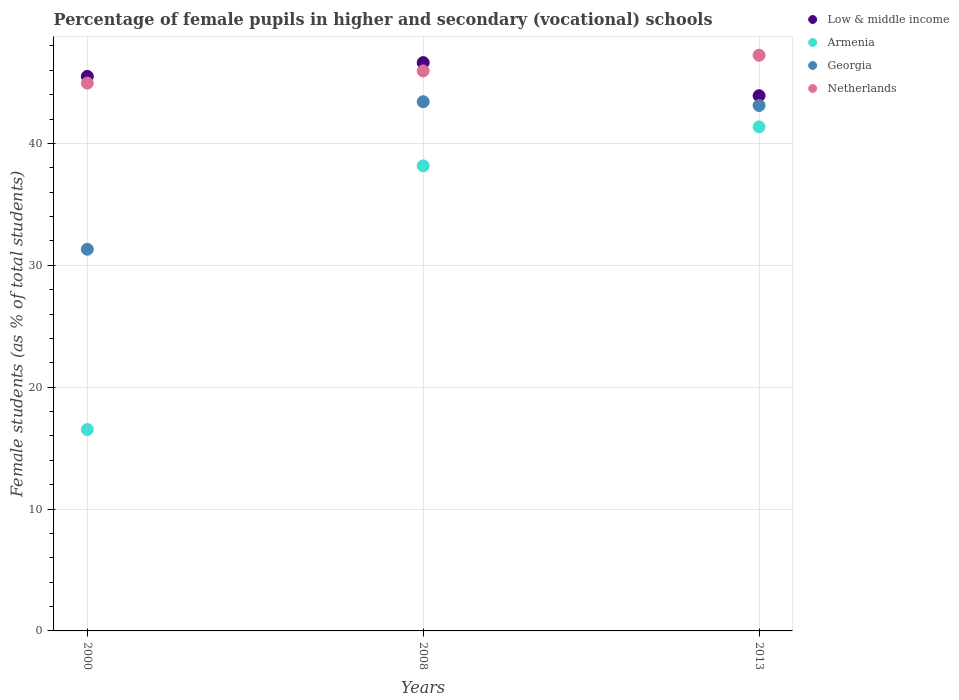How many different coloured dotlines are there?
Offer a very short reply. 4. Is the number of dotlines equal to the number of legend labels?
Your answer should be very brief. Yes. What is the percentage of female pupils in higher and secondary schools in Armenia in 2008?
Provide a succinct answer. 38.16. Across all years, what is the maximum percentage of female pupils in higher and secondary schools in Armenia?
Your answer should be very brief. 41.35. Across all years, what is the minimum percentage of female pupils in higher and secondary schools in Low & middle income?
Ensure brevity in your answer.  43.91. In which year was the percentage of female pupils in higher and secondary schools in Netherlands maximum?
Offer a very short reply. 2013. In which year was the percentage of female pupils in higher and secondary schools in Armenia minimum?
Offer a very short reply. 2000. What is the total percentage of female pupils in higher and secondary schools in Netherlands in the graph?
Provide a short and direct response. 138.12. What is the difference between the percentage of female pupils in higher and secondary schools in Georgia in 2008 and that in 2013?
Offer a terse response. 0.31. What is the difference between the percentage of female pupils in higher and secondary schools in Netherlands in 2013 and the percentage of female pupils in higher and secondary schools in Low & middle income in 2000?
Make the answer very short. 1.73. What is the average percentage of female pupils in higher and secondary schools in Netherlands per year?
Your answer should be very brief. 46.04. In the year 2013, what is the difference between the percentage of female pupils in higher and secondary schools in Netherlands and percentage of female pupils in higher and secondary schools in Low & middle income?
Make the answer very short. 3.32. What is the ratio of the percentage of female pupils in higher and secondary schools in Low & middle income in 2008 to that in 2013?
Provide a succinct answer. 1.06. What is the difference between the highest and the second highest percentage of female pupils in higher and secondary schools in Armenia?
Provide a short and direct response. 3.2. What is the difference between the highest and the lowest percentage of female pupils in higher and secondary schools in Georgia?
Ensure brevity in your answer.  12.1. In how many years, is the percentage of female pupils in higher and secondary schools in Georgia greater than the average percentage of female pupils in higher and secondary schools in Georgia taken over all years?
Your answer should be very brief. 2. Is the sum of the percentage of female pupils in higher and secondary schools in Netherlands in 2000 and 2013 greater than the maximum percentage of female pupils in higher and secondary schools in Georgia across all years?
Give a very brief answer. Yes. Is the percentage of female pupils in higher and secondary schools in Netherlands strictly greater than the percentage of female pupils in higher and secondary schools in Low & middle income over the years?
Your answer should be compact. No. What is the difference between two consecutive major ticks on the Y-axis?
Provide a short and direct response. 10. Does the graph contain any zero values?
Provide a succinct answer. No. Does the graph contain grids?
Provide a short and direct response. Yes. How many legend labels are there?
Make the answer very short. 4. What is the title of the graph?
Your answer should be very brief. Percentage of female pupils in higher and secondary (vocational) schools. What is the label or title of the X-axis?
Ensure brevity in your answer.  Years. What is the label or title of the Y-axis?
Give a very brief answer. Female students (as % of total students). What is the Female students (as % of total students) of Low & middle income in 2000?
Ensure brevity in your answer.  45.5. What is the Female students (as % of total students) in Armenia in 2000?
Your answer should be compact. 16.52. What is the Female students (as % of total students) of Georgia in 2000?
Make the answer very short. 31.31. What is the Female students (as % of total students) of Netherlands in 2000?
Make the answer very short. 44.94. What is the Female students (as % of total students) in Low & middle income in 2008?
Your answer should be very brief. 46.63. What is the Female students (as % of total students) of Armenia in 2008?
Keep it short and to the point. 38.16. What is the Female students (as % of total students) in Georgia in 2008?
Your answer should be very brief. 43.42. What is the Female students (as % of total students) of Netherlands in 2008?
Keep it short and to the point. 45.95. What is the Female students (as % of total students) in Low & middle income in 2013?
Provide a succinct answer. 43.91. What is the Female students (as % of total students) of Armenia in 2013?
Provide a succinct answer. 41.35. What is the Female students (as % of total students) in Georgia in 2013?
Provide a short and direct response. 43.11. What is the Female students (as % of total students) in Netherlands in 2013?
Keep it short and to the point. 47.23. Across all years, what is the maximum Female students (as % of total students) of Low & middle income?
Your answer should be compact. 46.63. Across all years, what is the maximum Female students (as % of total students) of Armenia?
Your answer should be very brief. 41.35. Across all years, what is the maximum Female students (as % of total students) of Georgia?
Keep it short and to the point. 43.42. Across all years, what is the maximum Female students (as % of total students) of Netherlands?
Provide a short and direct response. 47.23. Across all years, what is the minimum Female students (as % of total students) of Low & middle income?
Keep it short and to the point. 43.91. Across all years, what is the minimum Female students (as % of total students) of Armenia?
Keep it short and to the point. 16.52. Across all years, what is the minimum Female students (as % of total students) in Georgia?
Offer a terse response. 31.31. Across all years, what is the minimum Female students (as % of total students) of Netherlands?
Provide a short and direct response. 44.94. What is the total Female students (as % of total students) of Low & middle income in the graph?
Offer a terse response. 136.03. What is the total Female students (as % of total students) in Armenia in the graph?
Offer a very short reply. 96.03. What is the total Female students (as % of total students) in Georgia in the graph?
Your answer should be compact. 117.84. What is the total Female students (as % of total students) of Netherlands in the graph?
Offer a terse response. 138.12. What is the difference between the Female students (as % of total students) in Low & middle income in 2000 and that in 2008?
Your answer should be compact. -1.13. What is the difference between the Female students (as % of total students) of Armenia in 2000 and that in 2008?
Offer a very short reply. -21.63. What is the difference between the Female students (as % of total students) of Georgia in 2000 and that in 2008?
Provide a succinct answer. -12.1. What is the difference between the Female students (as % of total students) in Netherlands in 2000 and that in 2008?
Give a very brief answer. -1. What is the difference between the Female students (as % of total students) in Low & middle income in 2000 and that in 2013?
Provide a short and direct response. 1.58. What is the difference between the Female students (as % of total students) of Armenia in 2000 and that in 2013?
Keep it short and to the point. -24.83. What is the difference between the Female students (as % of total students) in Georgia in 2000 and that in 2013?
Offer a terse response. -11.8. What is the difference between the Female students (as % of total students) in Netherlands in 2000 and that in 2013?
Your answer should be compact. -2.28. What is the difference between the Female students (as % of total students) of Low & middle income in 2008 and that in 2013?
Ensure brevity in your answer.  2.71. What is the difference between the Female students (as % of total students) in Armenia in 2008 and that in 2013?
Your answer should be very brief. -3.2. What is the difference between the Female students (as % of total students) in Georgia in 2008 and that in 2013?
Your answer should be very brief. 0.31. What is the difference between the Female students (as % of total students) of Netherlands in 2008 and that in 2013?
Provide a succinct answer. -1.28. What is the difference between the Female students (as % of total students) of Low & middle income in 2000 and the Female students (as % of total students) of Armenia in 2008?
Make the answer very short. 7.34. What is the difference between the Female students (as % of total students) in Low & middle income in 2000 and the Female students (as % of total students) in Georgia in 2008?
Your answer should be compact. 2.08. What is the difference between the Female students (as % of total students) in Low & middle income in 2000 and the Female students (as % of total students) in Netherlands in 2008?
Provide a short and direct response. -0.45. What is the difference between the Female students (as % of total students) in Armenia in 2000 and the Female students (as % of total students) in Georgia in 2008?
Offer a very short reply. -26.9. What is the difference between the Female students (as % of total students) of Armenia in 2000 and the Female students (as % of total students) of Netherlands in 2008?
Provide a short and direct response. -29.42. What is the difference between the Female students (as % of total students) of Georgia in 2000 and the Female students (as % of total students) of Netherlands in 2008?
Offer a terse response. -14.63. What is the difference between the Female students (as % of total students) in Low & middle income in 2000 and the Female students (as % of total students) in Armenia in 2013?
Make the answer very short. 4.14. What is the difference between the Female students (as % of total students) in Low & middle income in 2000 and the Female students (as % of total students) in Georgia in 2013?
Your answer should be very brief. 2.39. What is the difference between the Female students (as % of total students) of Low & middle income in 2000 and the Female students (as % of total students) of Netherlands in 2013?
Give a very brief answer. -1.73. What is the difference between the Female students (as % of total students) in Armenia in 2000 and the Female students (as % of total students) in Georgia in 2013?
Keep it short and to the point. -26.59. What is the difference between the Female students (as % of total students) of Armenia in 2000 and the Female students (as % of total students) of Netherlands in 2013?
Provide a succinct answer. -30.7. What is the difference between the Female students (as % of total students) of Georgia in 2000 and the Female students (as % of total students) of Netherlands in 2013?
Give a very brief answer. -15.91. What is the difference between the Female students (as % of total students) in Low & middle income in 2008 and the Female students (as % of total students) in Armenia in 2013?
Offer a terse response. 5.27. What is the difference between the Female students (as % of total students) in Low & middle income in 2008 and the Female students (as % of total students) in Georgia in 2013?
Make the answer very short. 3.52. What is the difference between the Female students (as % of total students) of Low & middle income in 2008 and the Female students (as % of total students) of Netherlands in 2013?
Your response must be concise. -0.6. What is the difference between the Female students (as % of total students) of Armenia in 2008 and the Female students (as % of total students) of Georgia in 2013?
Your response must be concise. -4.95. What is the difference between the Female students (as % of total students) in Armenia in 2008 and the Female students (as % of total students) in Netherlands in 2013?
Ensure brevity in your answer.  -9.07. What is the difference between the Female students (as % of total students) of Georgia in 2008 and the Female students (as % of total students) of Netherlands in 2013?
Your answer should be very brief. -3.81. What is the average Female students (as % of total students) of Low & middle income per year?
Your answer should be very brief. 45.34. What is the average Female students (as % of total students) of Armenia per year?
Offer a terse response. 32.01. What is the average Female students (as % of total students) in Georgia per year?
Your response must be concise. 39.28. What is the average Female students (as % of total students) in Netherlands per year?
Make the answer very short. 46.04. In the year 2000, what is the difference between the Female students (as % of total students) of Low & middle income and Female students (as % of total students) of Armenia?
Offer a terse response. 28.97. In the year 2000, what is the difference between the Female students (as % of total students) of Low & middle income and Female students (as % of total students) of Georgia?
Provide a short and direct response. 14.18. In the year 2000, what is the difference between the Female students (as % of total students) of Low & middle income and Female students (as % of total students) of Netherlands?
Give a very brief answer. 0.55. In the year 2000, what is the difference between the Female students (as % of total students) in Armenia and Female students (as % of total students) in Georgia?
Your answer should be compact. -14.79. In the year 2000, what is the difference between the Female students (as % of total students) in Armenia and Female students (as % of total students) in Netherlands?
Ensure brevity in your answer.  -28.42. In the year 2000, what is the difference between the Female students (as % of total students) in Georgia and Female students (as % of total students) in Netherlands?
Make the answer very short. -13.63. In the year 2008, what is the difference between the Female students (as % of total students) in Low & middle income and Female students (as % of total students) in Armenia?
Offer a very short reply. 8.47. In the year 2008, what is the difference between the Female students (as % of total students) of Low & middle income and Female students (as % of total students) of Georgia?
Ensure brevity in your answer.  3.21. In the year 2008, what is the difference between the Female students (as % of total students) in Low & middle income and Female students (as % of total students) in Netherlands?
Make the answer very short. 0.68. In the year 2008, what is the difference between the Female students (as % of total students) of Armenia and Female students (as % of total students) of Georgia?
Your response must be concise. -5.26. In the year 2008, what is the difference between the Female students (as % of total students) of Armenia and Female students (as % of total students) of Netherlands?
Offer a very short reply. -7.79. In the year 2008, what is the difference between the Female students (as % of total students) in Georgia and Female students (as % of total students) in Netherlands?
Keep it short and to the point. -2.53. In the year 2013, what is the difference between the Female students (as % of total students) in Low & middle income and Female students (as % of total students) in Armenia?
Your answer should be compact. 2.56. In the year 2013, what is the difference between the Female students (as % of total students) in Low & middle income and Female students (as % of total students) in Georgia?
Ensure brevity in your answer.  0.8. In the year 2013, what is the difference between the Female students (as % of total students) in Low & middle income and Female students (as % of total students) in Netherlands?
Provide a succinct answer. -3.32. In the year 2013, what is the difference between the Female students (as % of total students) of Armenia and Female students (as % of total students) of Georgia?
Provide a succinct answer. -1.76. In the year 2013, what is the difference between the Female students (as % of total students) in Armenia and Female students (as % of total students) in Netherlands?
Keep it short and to the point. -5.87. In the year 2013, what is the difference between the Female students (as % of total students) of Georgia and Female students (as % of total students) of Netherlands?
Your answer should be compact. -4.12. What is the ratio of the Female students (as % of total students) in Low & middle income in 2000 to that in 2008?
Offer a very short reply. 0.98. What is the ratio of the Female students (as % of total students) in Armenia in 2000 to that in 2008?
Provide a succinct answer. 0.43. What is the ratio of the Female students (as % of total students) in Georgia in 2000 to that in 2008?
Keep it short and to the point. 0.72. What is the ratio of the Female students (as % of total students) in Netherlands in 2000 to that in 2008?
Give a very brief answer. 0.98. What is the ratio of the Female students (as % of total students) in Low & middle income in 2000 to that in 2013?
Provide a short and direct response. 1.04. What is the ratio of the Female students (as % of total students) in Armenia in 2000 to that in 2013?
Offer a very short reply. 0.4. What is the ratio of the Female students (as % of total students) in Georgia in 2000 to that in 2013?
Give a very brief answer. 0.73. What is the ratio of the Female students (as % of total students) in Netherlands in 2000 to that in 2013?
Keep it short and to the point. 0.95. What is the ratio of the Female students (as % of total students) in Low & middle income in 2008 to that in 2013?
Your response must be concise. 1.06. What is the ratio of the Female students (as % of total students) of Armenia in 2008 to that in 2013?
Ensure brevity in your answer.  0.92. What is the ratio of the Female students (as % of total students) in Georgia in 2008 to that in 2013?
Your answer should be very brief. 1.01. What is the ratio of the Female students (as % of total students) in Netherlands in 2008 to that in 2013?
Give a very brief answer. 0.97. What is the difference between the highest and the second highest Female students (as % of total students) of Low & middle income?
Provide a succinct answer. 1.13. What is the difference between the highest and the second highest Female students (as % of total students) in Armenia?
Your answer should be very brief. 3.2. What is the difference between the highest and the second highest Female students (as % of total students) in Georgia?
Make the answer very short. 0.31. What is the difference between the highest and the second highest Female students (as % of total students) of Netherlands?
Give a very brief answer. 1.28. What is the difference between the highest and the lowest Female students (as % of total students) in Low & middle income?
Provide a short and direct response. 2.71. What is the difference between the highest and the lowest Female students (as % of total students) in Armenia?
Provide a short and direct response. 24.83. What is the difference between the highest and the lowest Female students (as % of total students) of Georgia?
Ensure brevity in your answer.  12.1. What is the difference between the highest and the lowest Female students (as % of total students) in Netherlands?
Keep it short and to the point. 2.28. 